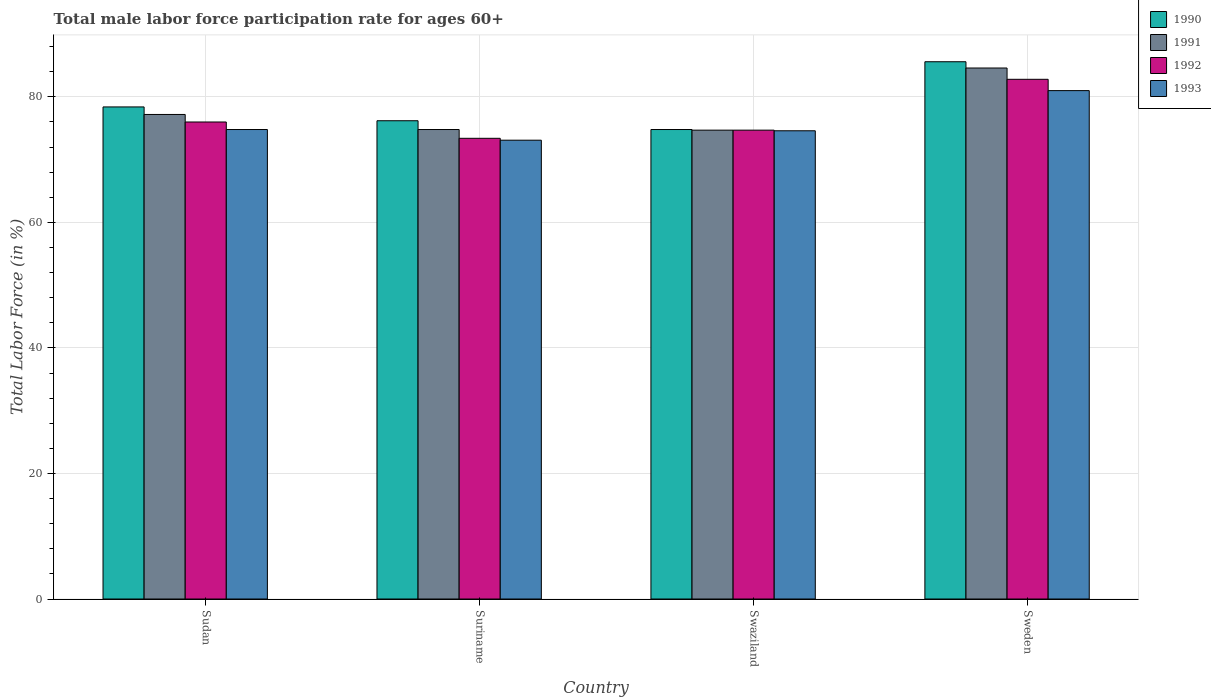Are the number of bars per tick equal to the number of legend labels?
Provide a short and direct response. Yes. How many bars are there on the 3rd tick from the left?
Your response must be concise. 4. How many bars are there on the 3rd tick from the right?
Offer a very short reply. 4. What is the label of the 3rd group of bars from the left?
Your answer should be compact. Swaziland. What is the male labor force participation rate in 1993 in Sweden?
Make the answer very short. 81. Across all countries, what is the maximum male labor force participation rate in 1990?
Give a very brief answer. 85.6. Across all countries, what is the minimum male labor force participation rate in 1990?
Your response must be concise. 74.8. In which country was the male labor force participation rate in 1990 minimum?
Your answer should be compact. Swaziland. What is the total male labor force participation rate in 1990 in the graph?
Provide a succinct answer. 315. What is the difference between the male labor force participation rate in 1993 in Sudan and that in Swaziland?
Your answer should be compact. 0.2. What is the difference between the male labor force participation rate in 1991 in Swaziland and the male labor force participation rate in 1990 in Sudan?
Your answer should be very brief. -3.7. What is the average male labor force participation rate in 1993 per country?
Your answer should be compact. 75.87. What is the difference between the male labor force participation rate of/in 1993 and male labor force participation rate of/in 1992 in Suriname?
Keep it short and to the point. -0.3. In how many countries, is the male labor force participation rate in 1993 greater than 32 %?
Keep it short and to the point. 4. What is the ratio of the male labor force participation rate in 1991 in Swaziland to that in Sweden?
Make the answer very short. 0.88. Is the male labor force participation rate in 1991 in Swaziland less than that in Sweden?
Provide a short and direct response. Yes. What is the difference between the highest and the second highest male labor force participation rate in 1993?
Ensure brevity in your answer.  6.2. What is the difference between the highest and the lowest male labor force participation rate in 1992?
Give a very brief answer. 9.4. In how many countries, is the male labor force participation rate in 1990 greater than the average male labor force participation rate in 1990 taken over all countries?
Keep it short and to the point. 1. What does the 4th bar from the right in Suriname represents?
Your response must be concise. 1990. How many bars are there?
Provide a succinct answer. 16. Are all the bars in the graph horizontal?
Ensure brevity in your answer.  No. How many countries are there in the graph?
Your answer should be compact. 4. Does the graph contain any zero values?
Your response must be concise. No. Does the graph contain grids?
Your answer should be very brief. Yes. How many legend labels are there?
Provide a short and direct response. 4. What is the title of the graph?
Provide a short and direct response. Total male labor force participation rate for ages 60+. What is the label or title of the Y-axis?
Give a very brief answer. Total Labor Force (in %). What is the Total Labor Force (in %) in 1990 in Sudan?
Give a very brief answer. 78.4. What is the Total Labor Force (in %) in 1991 in Sudan?
Your answer should be compact. 77.2. What is the Total Labor Force (in %) in 1993 in Sudan?
Give a very brief answer. 74.8. What is the Total Labor Force (in %) of 1990 in Suriname?
Make the answer very short. 76.2. What is the Total Labor Force (in %) of 1991 in Suriname?
Offer a terse response. 74.8. What is the Total Labor Force (in %) in 1992 in Suriname?
Keep it short and to the point. 73.4. What is the Total Labor Force (in %) in 1993 in Suriname?
Your answer should be very brief. 73.1. What is the Total Labor Force (in %) of 1990 in Swaziland?
Provide a short and direct response. 74.8. What is the Total Labor Force (in %) in 1991 in Swaziland?
Provide a succinct answer. 74.7. What is the Total Labor Force (in %) of 1992 in Swaziland?
Provide a short and direct response. 74.7. What is the Total Labor Force (in %) in 1993 in Swaziland?
Make the answer very short. 74.6. What is the Total Labor Force (in %) in 1990 in Sweden?
Provide a short and direct response. 85.6. What is the Total Labor Force (in %) of 1991 in Sweden?
Keep it short and to the point. 84.6. What is the Total Labor Force (in %) of 1992 in Sweden?
Your answer should be very brief. 82.8. What is the Total Labor Force (in %) in 1993 in Sweden?
Give a very brief answer. 81. Across all countries, what is the maximum Total Labor Force (in %) in 1990?
Keep it short and to the point. 85.6. Across all countries, what is the maximum Total Labor Force (in %) in 1991?
Offer a terse response. 84.6. Across all countries, what is the maximum Total Labor Force (in %) in 1992?
Provide a succinct answer. 82.8. Across all countries, what is the minimum Total Labor Force (in %) in 1990?
Your response must be concise. 74.8. Across all countries, what is the minimum Total Labor Force (in %) in 1991?
Your answer should be compact. 74.7. Across all countries, what is the minimum Total Labor Force (in %) of 1992?
Your answer should be compact. 73.4. Across all countries, what is the minimum Total Labor Force (in %) in 1993?
Your answer should be compact. 73.1. What is the total Total Labor Force (in %) of 1990 in the graph?
Provide a succinct answer. 315. What is the total Total Labor Force (in %) of 1991 in the graph?
Offer a terse response. 311.3. What is the total Total Labor Force (in %) in 1992 in the graph?
Provide a short and direct response. 306.9. What is the total Total Labor Force (in %) of 1993 in the graph?
Make the answer very short. 303.5. What is the difference between the Total Labor Force (in %) in 1990 in Sudan and that in Suriname?
Provide a short and direct response. 2.2. What is the difference between the Total Labor Force (in %) of 1993 in Sudan and that in Suriname?
Offer a very short reply. 1.7. What is the difference between the Total Labor Force (in %) of 1990 in Sudan and that in Swaziland?
Keep it short and to the point. 3.6. What is the difference between the Total Labor Force (in %) of 1992 in Sudan and that in Swaziland?
Your answer should be very brief. 1.3. What is the difference between the Total Labor Force (in %) in 1991 in Suriname and that in Swaziland?
Offer a terse response. 0.1. What is the difference between the Total Labor Force (in %) of 1992 in Suriname and that in Swaziland?
Make the answer very short. -1.3. What is the difference between the Total Labor Force (in %) in 1993 in Suriname and that in Swaziland?
Your response must be concise. -1.5. What is the difference between the Total Labor Force (in %) of 1993 in Suriname and that in Sweden?
Your response must be concise. -7.9. What is the difference between the Total Labor Force (in %) of 1992 in Swaziland and that in Sweden?
Your answer should be very brief. -8.1. What is the difference between the Total Labor Force (in %) in 1990 in Sudan and the Total Labor Force (in %) in 1991 in Suriname?
Your answer should be compact. 3.6. What is the difference between the Total Labor Force (in %) of 1990 in Sudan and the Total Labor Force (in %) of 1992 in Suriname?
Offer a very short reply. 5. What is the difference between the Total Labor Force (in %) in 1991 in Sudan and the Total Labor Force (in %) in 1993 in Suriname?
Your response must be concise. 4.1. What is the difference between the Total Labor Force (in %) of 1992 in Sudan and the Total Labor Force (in %) of 1993 in Suriname?
Give a very brief answer. 2.9. What is the difference between the Total Labor Force (in %) in 1990 in Sudan and the Total Labor Force (in %) in 1991 in Swaziland?
Make the answer very short. 3.7. What is the difference between the Total Labor Force (in %) in 1990 in Sudan and the Total Labor Force (in %) in 1992 in Swaziland?
Ensure brevity in your answer.  3.7. What is the difference between the Total Labor Force (in %) in 1990 in Sudan and the Total Labor Force (in %) in 1993 in Swaziland?
Your response must be concise. 3.8. What is the difference between the Total Labor Force (in %) of 1990 in Sudan and the Total Labor Force (in %) of 1991 in Sweden?
Ensure brevity in your answer.  -6.2. What is the difference between the Total Labor Force (in %) of 1990 in Sudan and the Total Labor Force (in %) of 1993 in Sweden?
Make the answer very short. -2.6. What is the difference between the Total Labor Force (in %) of 1991 in Sudan and the Total Labor Force (in %) of 1992 in Sweden?
Ensure brevity in your answer.  -5.6. What is the difference between the Total Labor Force (in %) of 1991 in Sudan and the Total Labor Force (in %) of 1993 in Sweden?
Offer a terse response. -3.8. What is the difference between the Total Labor Force (in %) of 1990 in Suriname and the Total Labor Force (in %) of 1992 in Swaziland?
Provide a short and direct response. 1.5. What is the difference between the Total Labor Force (in %) in 1990 in Suriname and the Total Labor Force (in %) in 1993 in Swaziland?
Ensure brevity in your answer.  1.6. What is the difference between the Total Labor Force (in %) of 1992 in Suriname and the Total Labor Force (in %) of 1993 in Swaziland?
Your answer should be very brief. -1.2. What is the difference between the Total Labor Force (in %) in 1990 in Suriname and the Total Labor Force (in %) in 1991 in Sweden?
Your answer should be compact. -8.4. What is the difference between the Total Labor Force (in %) of 1990 in Suriname and the Total Labor Force (in %) of 1993 in Sweden?
Provide a succinct answer. -4.8. What is the difference between the Total Labor Force (in %) of 1990 in Swaziland and the Total Labor Force (in %) of 1991 in Sweden?
Your response must be concise. -9.8. What is the difference between the Total Labor Force (in %) in 1991 in Swaziland and the Total Labor Force (in %) in 1992 in Sweden?
Offer a terse response. -8.1. What is the difference between the Total Labor Force (in %) of 1991 in Swaziland and the Total Labor Force (in %) of 1993 in Sweden?
Keep it short and to the point. -6.3. What is the average Total Labor Force (in %) in 1990 per country?
Your answer should be very brief. 78.75. What is the average Total Labor Force (in %) of 1991 per country?
Your response must be concise. 77.83. What is the average Total Labor Force (in %) in 1992 per country?
Make the answer very short. 76.72. What is the average Total Labor Force (in %) in 1993 per country?
Your answer should be very brief. 75.88. What is the difference between the Total Labor Force (in %) of 1991 and Total Labor Force (in %) of 1993 in Sudan?
Make the answer very short. 2.4. What is the difference between the Total Labor Force (in %) of 1990 and Total Labor Force (in %) of 1991 in Suriname?
Provide a succinct answer. 1.4. What is the difference between the Total Labor Force (in %) in 1990 and Total Labor Force (in %) in 1992 in Suriname?
Your answer should be very brief. 2.8. What is the difference between the Total Labor Force (in %) of 1990 and Total Labor Force (in %) of 1993 in Suriname?
Offer a terse response. 3.1. What is the difference between the Total Labor Force (in %) in 1991 and Total Labor Force (in %) in 1992 in Suriname?
Keep it short and to the point. 1.4. What is the difference between the Total Labor Force (in %) of 1991 and Total Labor Force (in %) of 1993 in Suriname?
Your answer should be compact. 1.7. What is the difference between the Total Labor Force (in %) in 1992 and Total Labor Force (in %) in 1993 in Suriname?
Offer a very short reply. 0.3. What is the difference between the Total Labor Force (in %) of 1990 and Total Labor Force (in %) of 1991 in Swaziland?
Ensure brevity in your answer.  0.1. What is the difference between the Total Labor Force (in %) of 1990 and Total Labor Force (in %) of 1992 in Swaziland?
Your answer should be very brief. 0.1. What is the difference between the Total Labor Force (in %) in 1990 and Total Labor Force (in %) in 1993 in Swaziland?
Provide a short and direct response. 0.2. What is the difference between the Total Labor Force (in %) of 1991 and Total Labor Force (in %) of 1992 in Swaziland?
Your answer should be compact. 0. What is the difference between the Total Labor Force (in %) of 1991 and Total Labor Force (in %) of 1993 in Swaziland?
Give a very brief answer. 0.1. What is the difference between the Total Labor Force (in %) in 1990 and Total Labor Force (in %) in 1991 in Sweden?
Offer a very short reply. 1. What is the difference between the Total Labor Force (in %) of 1991 and Total Labor Force (in %) of 1992 in Sweden?
Your answer should be compact. 1.8. What is the difference between the Total Labor Force (in %) in 1991 and Total Labor Force (in %) in 1993 in Sweden?
Provide a short and direct response. 3.6. What is the difference between the Total Labor Force (in %) in 1992 and Total Labor Force (in %) in 1993 in Sweden?
Offer a very short reply. 1.8. What is the ratio of the Total Labor Force (in %) in 1990 in Sudan to that in Suriname?
Your answer should be compact. 1.03. What is the ratio of the Total Labor Force (in %) of 1991 in Sudan to that in Suriname?
Your answer should be compact. 1.03. What is the ratio of the Total Labor Force (in %) of 1992 in Sudan to that in Suriname?
Make the answer very short. 1.04. What is the ratio of the Total Labor Force (in %) in 1993 in Sudan to that in Suriname?
Your answer should be very brief. 1.02. What is the ratio of the Total Labor Force (in %) of 1990 in Sudan to that in Swaziland?
Your answer should be very brief. 1.05. What is the ratio of the Total Labor Force (in %) in 1991 in Sudan to that in Swaziland?
Make the answer very short. 1.03. What is the ratio of the Total Labor Force (in %) of 1992 in Sudan to that in Swaziland?
Your response must be concise. 1.02. What is the ratio of the Total Labor Force (in %) of 1990 in Sudan to that in Sweden?
Make the answer very short. 0.92. What is the ratio of the Total Labor Force (in %) in 1991 in Sudan to that in Sweden?
Offer a terse response. 0.91. What is the ratio of the Total Labor Force (in %) in 1992 in Sudan to that in Sweden?
Ensure brevity in your answer.  0.92. What is the ratio of the Total Labor Force (in %) of 1993 in Sudan to that in Sweden?
Provide a succinct answer. 0.92. What is the ratio of the Total Labor Force (in %) in 1990 in Suriname to that in Swaziland?
Your answer should be compact. 1.02. What is the ratio of the Total Labor Force (in %) in 1991 in Suriname to that in Swaziland?
Your response must be concise. 1. What is the ratio of the Total Labor Force (in %) of 1992 in Suriname to that in Swaziland?
Provide a succinct answer. 0.98. What is the ratio of the Total Labor Force (in %) of 1993 in Suriname to that in Swaziland?
Offer a very short reply. 0.98. What is the ratio of the Total Labor Force (in %) in 1990 in Suriname to that in Sweden?
Offer a terse response. 0.89. What is the ratio of the Total Labor Force (in %) of 1991 in Suriname to that in Sweden?
Offer a terse response. 0.88. What is the ratio of the Total Labor Force (in %) in 1992 in Suriname to that in Sweden?
Offer a very short reply. 0.89. What is the ratio of the Total Labor Force (in %) in 1993 in Suriname to that in Sweden?
Give a very brief answer. 0.9. What is the ratio of the Total Labor Force (in %) in 1990 in Swaziland to that in Sweden?
Offer a very short reply. 0.87. What is the ratio of the Total Labor Force (in %) in 1991 in Swaziland to that in Sweden?
Give a very brief answer. 0.88. What is the ratio of the Total Labor Force (in %) of 1992 in Swaziland to that in Sweden?
Offer a very short reply. 0.9. What is the ratio of the Total Labor Force (in %) in 1993 in Swaziland to that in Sweden?
Your response must be concise. 0.92. What is the difference between the highest and the second highest Total Labor Force (in %) in 1991?
Your response must be concise. 7.4. What is the difference between the highest and the second highest Total Labor Force (in %) of 1993?
Offer a very short reply. 6.2. What is the difference between the highest and the lowest Total Labor Force (in %) of 1990?
Keep it short and to the point. 10.8. What is the difference between the highest and the lowest Total Labor Force (in %) of 1993?
Provide a short and direct response. 7.9. 